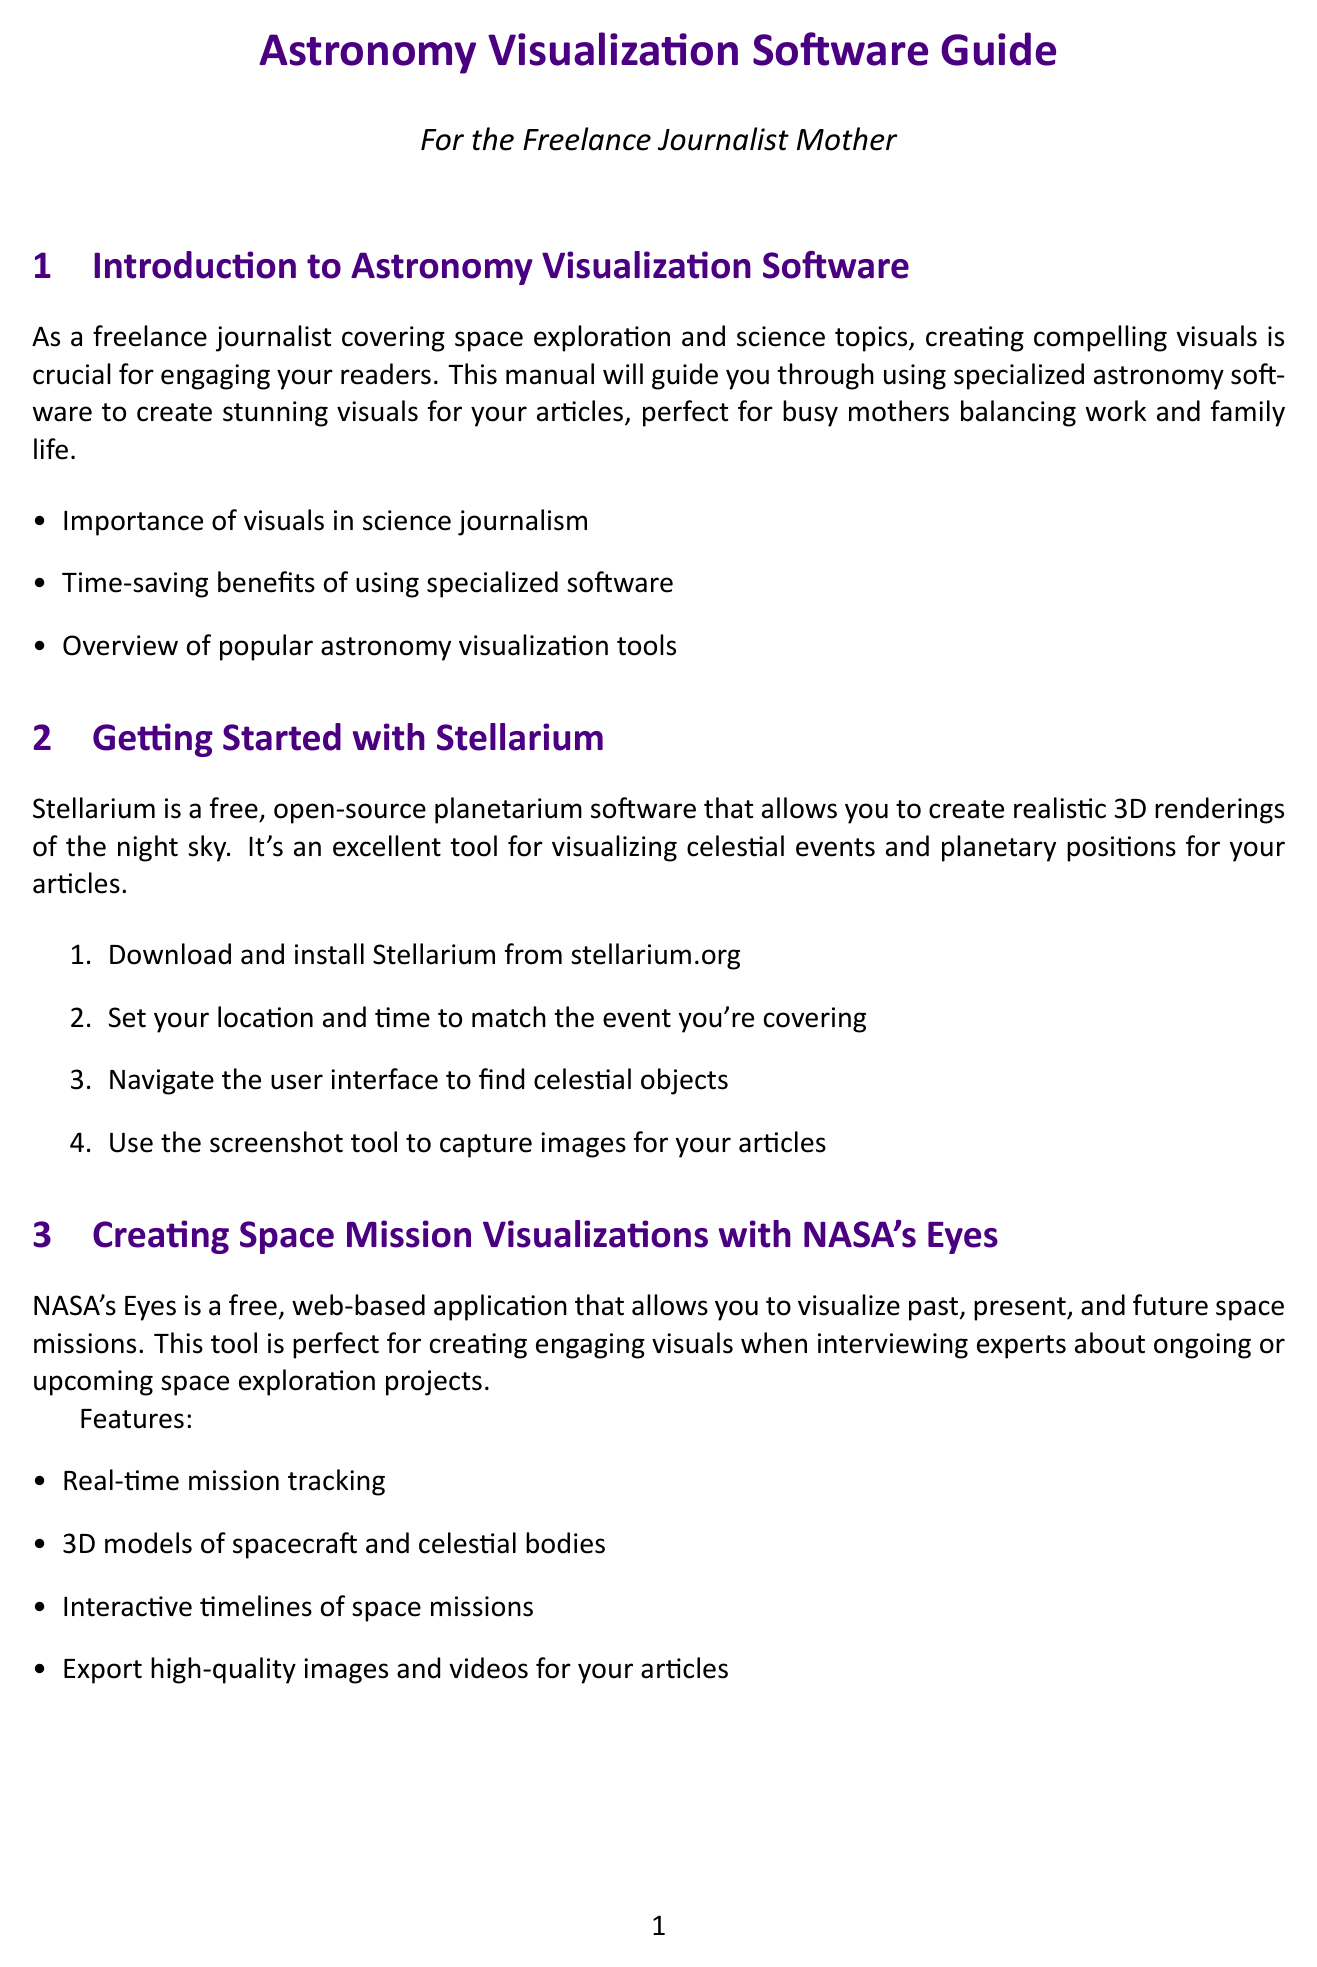What is the name of the open-source planetarium software mentioned? The document describes Stellarium as the free, open-source planetarium software for creating 3D renderings of the night sky.
Answer: Stellarium What should you set in Stellarium to match the event you're covering? The document states that you should set your location and time in Stellarium to match the event.
Answer: Location and time What is the website for NASA's Exoplanet Travel Bureau? The document includes the URL exoplanets.nasa.gov/alien-worlds/exoplanet-travel-bureau/ for accessing the Exoplanet Travel Bureau.
Answer: exoplanets.nasa.gov/alien-worlds/exoplanet-travel-bureau/ What type of content is WorldWide Telescope excellent for creating? According to the document, WorldWide Telescope is perfect for developing engaging online content to complement written articles.
Answer: Engaging online content Name one feature of NASA's Eyes. The document mentions multiple features, including real-time mission tracking, which is just one of them.
Answer: Real-time mission tracking What is one tip for balancing visual creation with parenting? The document lists several tips and one of them is to set up a dedicated workspace with minimal distractions.
Answer: Dedicated workspace What is a best practice for incorporating visuals in science journalism? The document suggests always including clear captions and credits for visuals as a best practice.
Answer: Clear captions and credits What type of visuals does NASA's Exoplanet Travel Bureau offer? The document states that NASA's Exoplanet Travel Bureau offers imaginative yet scientifically grounded visuals of exoplanets.
Answer: Imaginative yet scientifically grounded visuals How can you capture images in Stellarium? The document states that you can use the screenshot tool to capture images for your articles in Stellarium.
Answer: Screenshot tool 